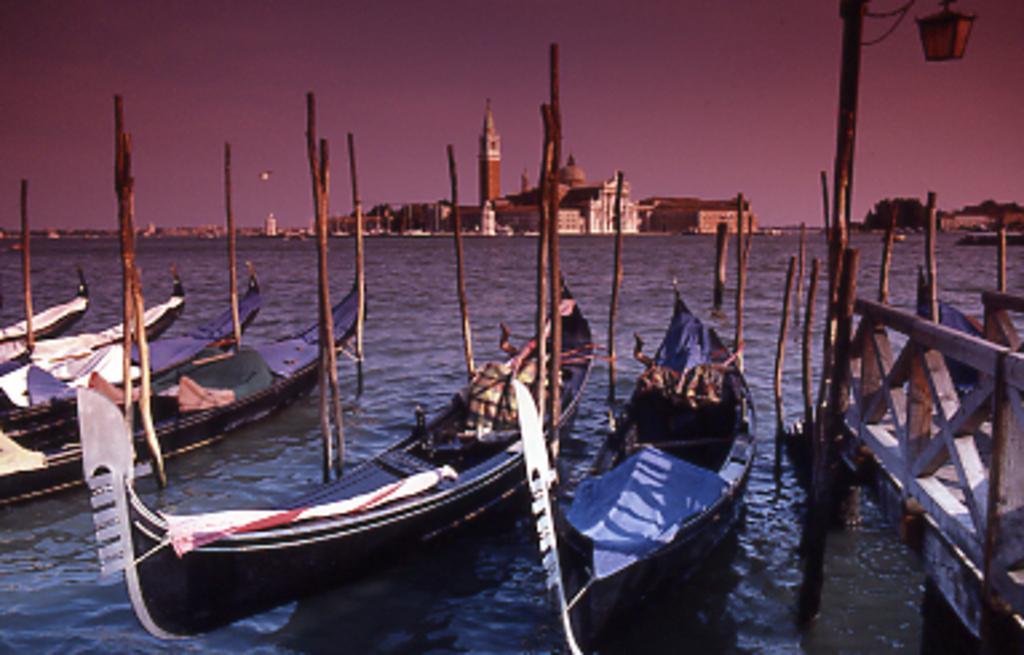Could you give a brief overview of what you see in this image? In this image I can see few boats on the water. I can also see a bridge, background I can see few buildings and I can see the sky. 